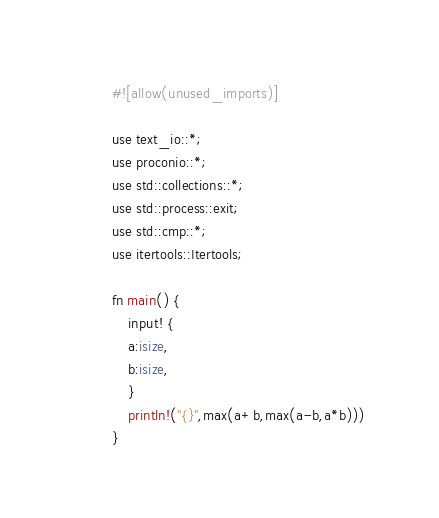<code> <loc_0><loc_0><loc_500><loc_500><_Rust_>#![allow(unused_imports)]

use text_io::*;
use proconio::*;
use std::collections::*;
use std::process::exit;
use std::cmp::*;
use itertools::Itertools;

fn main() {
    input! {
    a:isize,
    b:isize,
    }
    println!("{}",max(a+b,max(a-b,a*b)))
}</code> 